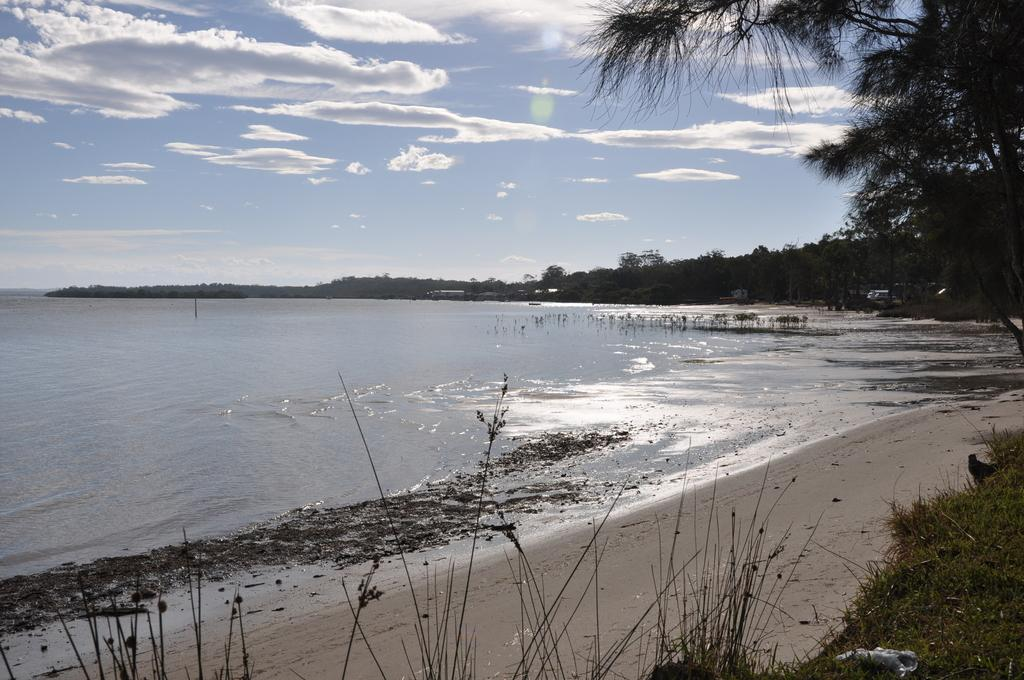What is the main feature in the center of the image? There is a sea in the center of the image. What type of vegetation is on the right side of the image? There are trees on the right side of the image. What can be seen in the background of the image? Hills and the sky are visible in the background of the image. What type of ground is at the bottom of the image? There is grass at the bottom of the image. What type of polish is being applied to the trees in the image? There is no indication in the image that any polish is being applied to the trees. 